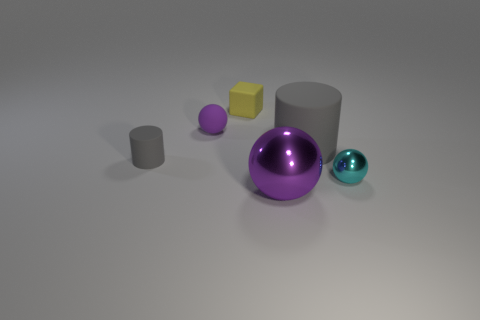Subtract all purple balls. How many were subtracted if there are1purple balls left? 1 Add 3 small balls. How many objects exist? 9 Subtract all blocks. How many objects are left? 5 Add 3 gray rubber cylinders. How many gray rubber cylinders are left? 5 Add 5 large gray objects. How many large gray objects exist? 6 Subtract 2 gray cylinders. How many objects are left? 4 Subtract all tiny yellow matte objects. Subtract all purple metal balls. How many objects are left? 4 